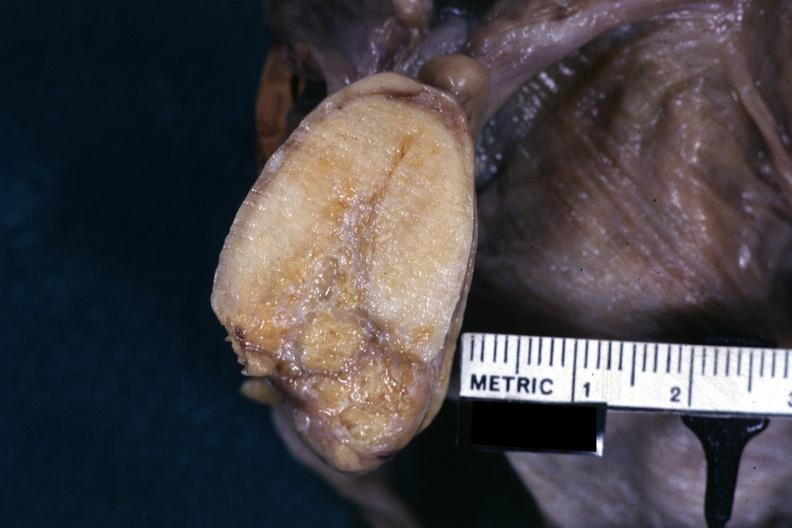s thecoma present?
Answer the question using a single word or phrase. Yes 